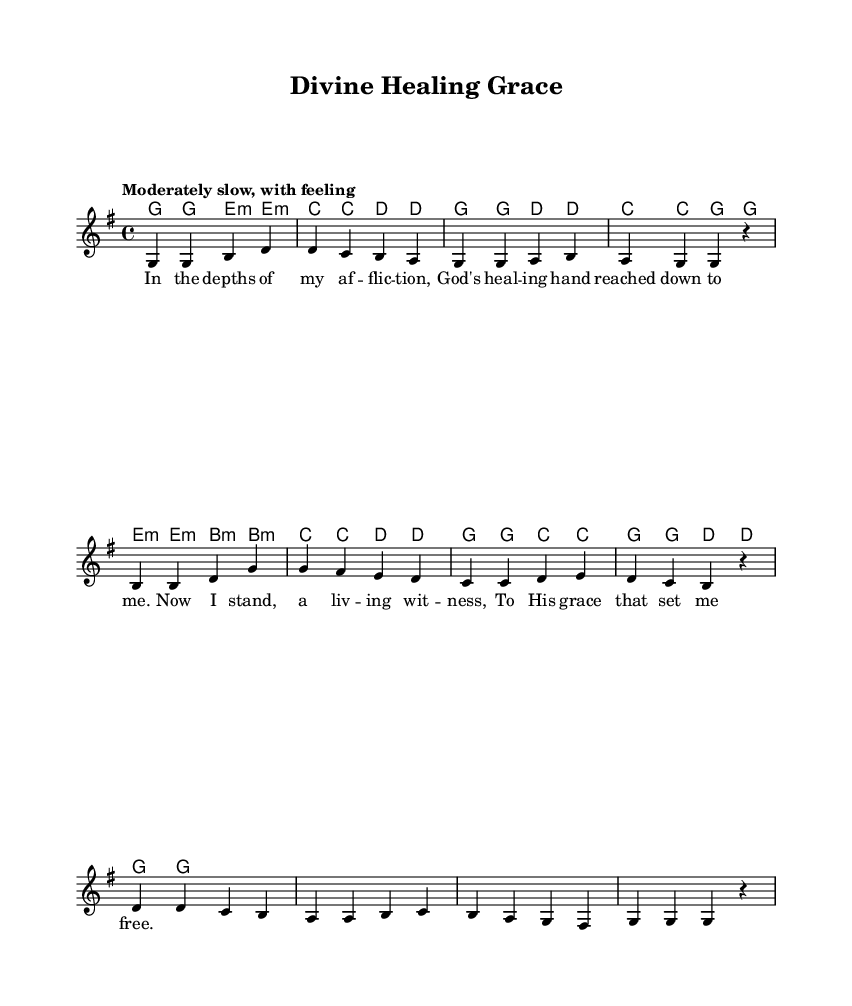What is the key signature of this music? The key signature indicated in the music is G major, which contains one sharp (F#). This can be seen in the initial part of the score under the global settings.
Answer: G major What is the time signature of this piece? The time signature, as shown in the global settings, is 4/4, which means there are four beats in each measure and each quarter note gets one beat.
Answer: 4/4 What is the tempo marking for this piece? The tempo marking is "Moderately slow, with feeling," which gives guidance on the desired speed and expression when playing the piece.
Answer: Moderately slow How many measures are there in the melody? By counting the measures represented in the melody portion of the score, we see there are a total of 8 measures.
Answer: 8 What is the first note of the melody? The first note in the melody is G, as indicated in the relative notation that starts with "g4."
Answer: G What is the lyrical theme of the hymn? The lyrics convey a theme of divine healing and the transformative experience of receiving God's grace during affliction—an element typical in Gospel hymns focused on healing.
Answer: Divine healing What is the chord progression used in the first line? The chord progression for the first line of the lyrics is G, Em, C, D, which outlines the harmony played beneath the melody that emphasizes the key changes supporting the lyrical content.
Answer: G, Em, C, D 